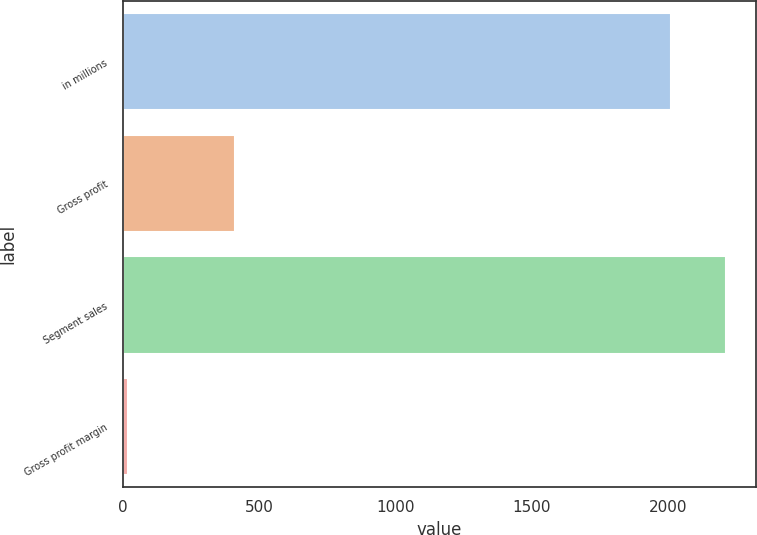Convert chart to OTSL. <chart><loc_0><loc_0><loc_500><loc_500><bar_chart><fcel>in millions<fcel>Gross profit<fcel>Segment sales<fcel>Gross profit margin<nl><fcel>2013<fcel>413.3<fcel>2213.46<fcel>20.4<nl></chart> 